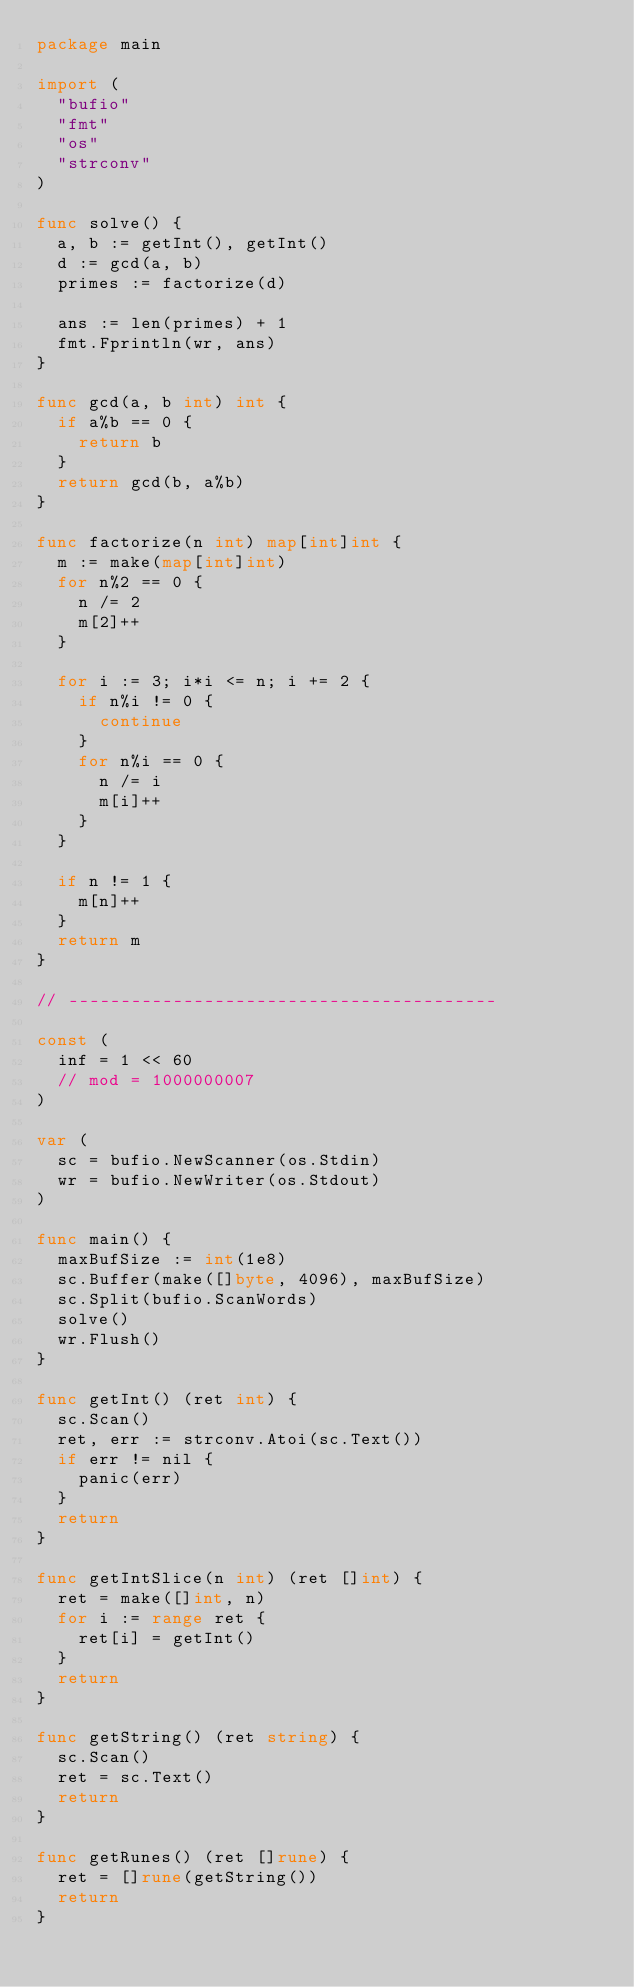Convert code to text. <code><loc_0><loc_0><loc_500><loc_500><_Go_>package main

import (
	"bufio"
	"fmt"
	"os"
	"strconv"
)

func solve() {
	a, b := getInt(), getInt()
	d := gcd(a, b)
	primes := factorize(d)

	ans := len(primes) + 1
	fmt.Fprintln(wr, ans)
}

func gcd(a, b int) int {
	if a%b == 0 {
		return b
	}
	return gcd(b, a%b)
}

func factorize(n int) map[int]int {
	m := make(map[int]int)
	for n%2 == 0 {
		n /= 2
		m[2]++
	}

	for i := 3; i*i <= n; i += 2 {
		if n%i != 0 {
			continue
		}
		for n%i == 0 {
			n /= i
			m[i]++
		}
	}

	if n != 1 {
		m[n]++
	}
	return m
}

// -----------------------------------------

const (
	inf = 1 << 60
	// mod = 1000000007
)

var (
	sc = bufio.NewScanner(os.Stdin)
	wr = bufio.NewWriter(os.Stdout)
)

func main() {
	maxBufSize := int(1e8)
	sc.Buffer(make([]byte, 4096), maxBufSize)
	sc.Split(bufio.ScanWords)
	solve()
	wr.Flush()
}

func getInt() (ret int) {
	sc.Scan()
	ret, err := strconv.Atoi(sc.Text())
	if err != nil {
		panic(err)
	}
	return
}

func getIntSlice(n int) (ret []int) {
	ret = make([]int, n)
	for i := range ret {
		ret[i] = getInt()
	}
	return
}

func getString() (ret string) {
	sc.Scan()
	ret = sc.Text()
	return
}

func getRunes() (ret []rune) {
	ret = []rune(getString())
	return
}
</code> 